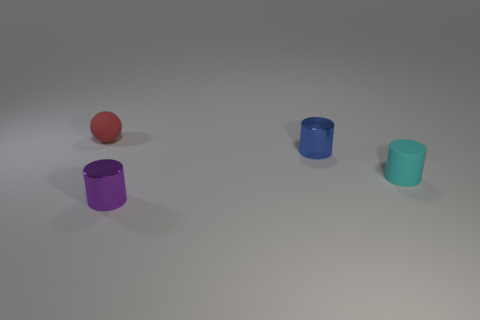What material is the cyan thing that is the same shape as the small blue metallic object?
Make the answer very short. Rubber. How many other objects are the same size as the cyan rubber cylinder?
Your answer should be compact. 3. Does the thing in front of the cyan object have the same shape as the tiny cyan object?
Provide a short and direct response. Yes. What number of other things are the same shape as the small red object?
Provide a succinct answer. 0. There is a small thing that is to the right of the small blue metallic cylinder; what is its shape?
Your answer should be very brief. Cylinder. Is there a block made of the same material as the tiny cyan object?
Your answer should be very brief. No. Does the tiny rubber thing that is in front of the tiny blue cylinder have the same color as the sphere?
Your response must be concise. No. The cyan rubber cylinder is what size?
Offer a terse response. Small. Is there a small red rubber ball behind the rubber thing behind the small rubber object that is in front of the small red matte object?
Provide a succinct answer. No. There is a tiny purple metal thing; what number of small cylinders are behind it?
Provide a succinct answer. 2. 